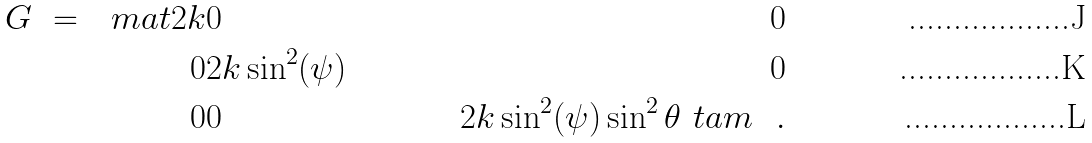Convert formula to latex. <formula><loc_0><loc_0><loc_500><loc_500>G \ = \ \ m a t 2 k & 0 & 0 \\ 0 & 2 k \sin ^ { 2 } ( \psi ) & 0 \\ 0 & 0 & 2 k \sin ^ { 2 } ( \psi ) \sin ^ { 2 } \theta \ t a m \ \ .</formula> 